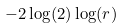<formula> <loc_0><loc_0><loc_500><loc_500>- 2 \log ( 2 ) \log ( r )</formula> 